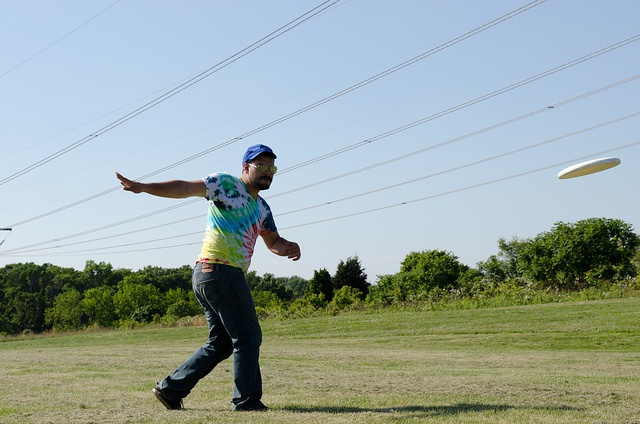Describe the objects in this image and their specific colors. I can see people in lightblue, black, gray, maroon, and teal tones and frisbee in lightblue, olive, white, and darkgray tones in this image. 